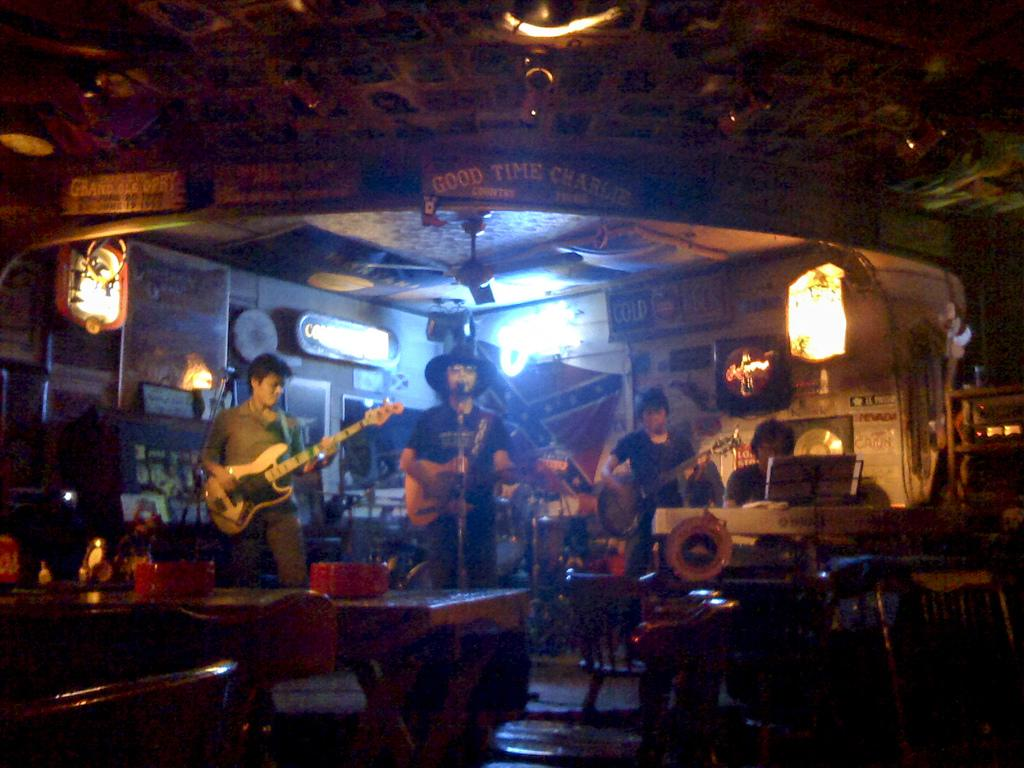What are the people in the image doing? The people in the image are standing and holding guitars. Is there anyone sitting in the image? Yes, there is a person sitting in the image. What type of furniture can be seen in the image? There are tables and chairs in the image. What religious symbols are present in the image? There are no religious symbols present in the image. What type of writing can be seen on the guitars in the image? There is no writing visible on the guitars in the image. 